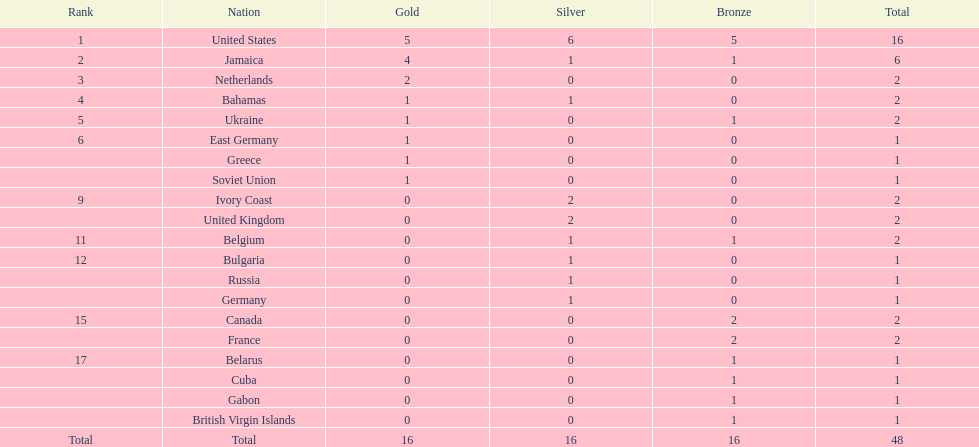How many nations won at least two gold medals? 3. Write the full table. {'header': ['Rank', 'Nation', 'Gold', 'Silver', 'Bronze', 'Total'], 'rows': [['1', 'United States', '5', '6', '5', '16'], ['2', 'Jamaica', '4', '1', '1', '6'], ['3', 'Netherlands', '2', '0', '0', '2'], ['4', 'Bahamas', '1', '1', '0', '2'], ['5', 'Ukraine', '1', '0', '1', '2'], ['6', 'East Germany', '1', '0', '0', '1'], ['', 'Greece', '1', '0', '0', '1'], ['', 'Soviet Union', '1', '0', '0', '1'], ['9', 'Ivory Coast', '0', '2', '0', '2'], ['', 'United Kingdom', '0', '2', '0', '2'], ['11', 'Belgium', '0', '1', '1', '2'], ['12', 'Bulgaria', '0', '1', '0', '1'], ['', 'Russia', '0', '1', '0', '1'], ['', 'Germany', '0', '1', '0', '1'], ['15', 'Canada', '0', '0', '2', '2'], ['', 'France', '0', '0', '2', '2'], ['17', 'Belarus', '0', '0', '1', '1'], ['', 'Cuba', '0', '0', '1', '1'], ['', 'Gabon', '0', '0', '1', '1'], ['', 'British Virgin Islands', '0', '0', '1', '1'], ['Total', 'Total', '16', '16', '16', '48']]} 